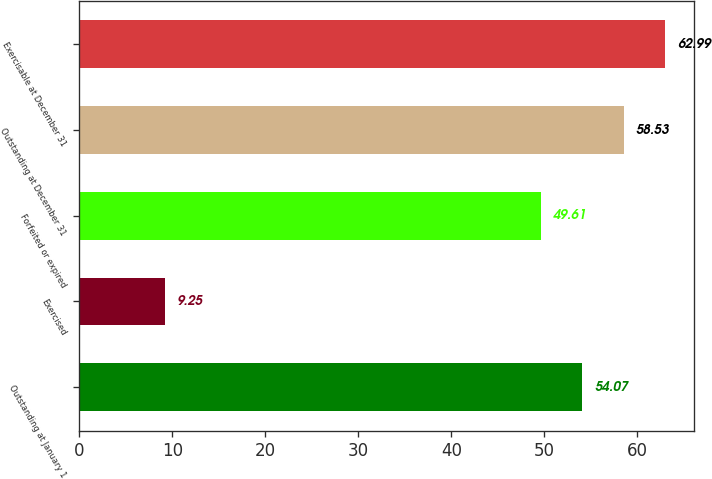<chart> <loc_0><loc_0><loc_500><loc_500><bar_chart><fcel>Outstanding at January 1<fcel>Exercised<fcel>Forfeited or expired<fcel>Outstanding at December 31<fcel>Exercisable at December 31<nl><fcel>54.07<fcel>9.25<fcel>49.61<fcel>58.53<fcel>62.99<nl></chart> 